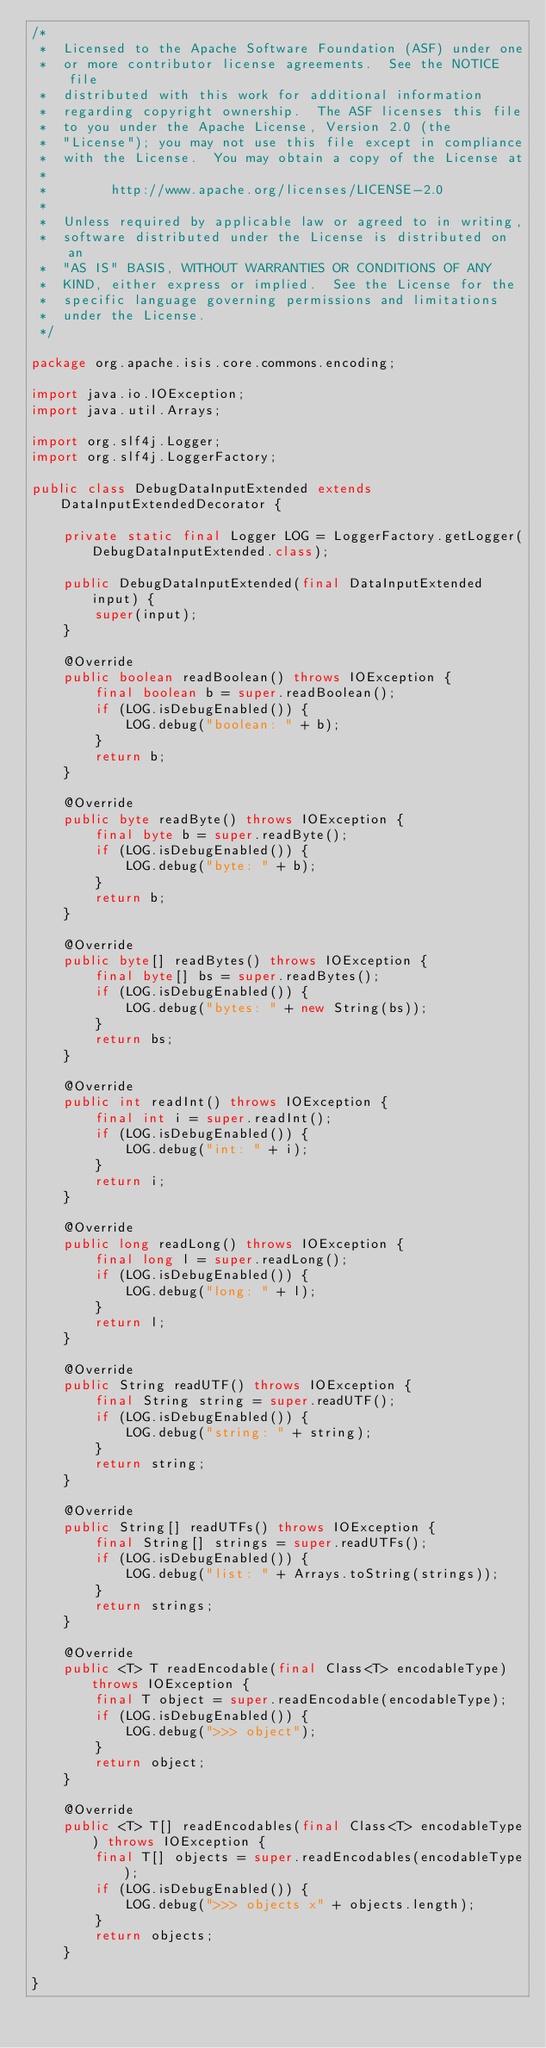Convert code to text. <code><loc_0><loc_0><loc_500><loc_500><_Java_>/*
 *  Licensed to the Apache Software Foundation (ASF) under one
 *  or more contributor license agreements.  See the NOTICE file
 *  distributed with this work for additional information
 *  regarding copyright ownership.  The ASF licenses this file
 *  to you under the Apache License, Version 2.0 (the
 *  "License"); you may not use this file except in compliance
 *  with the License.  You may obtain a copy of the License at
 *
 *        http://www.apache.org/licenses/LICENSE-2.0
 *
 *  Unless required by applicable law or agreed to in writing,
 *  software distributed under the License is distributed on an
 *  "AS IS" BASIS, WITHOUT WARRANTIES OR CONDITIONS OF ANY
 *  KIND, either express or implied.  See the License for the
 *  specific language governing permissions and limitations
 *  under the License.
 */

package org.apache.isis.core.commons.encoding;

import java.io.IOException;
import java.util.Arrays;

import org.slf4j.Logger;
import org.slf4j.LoggerFactory;

public class DebugDataInputExtended extends DataInputExtendedDecorator {

    private static final Logger LOG = LoggerFactory.getLogger(DebugDataInputExtended.class);

    public DebugDataInputExtended(final DataInputExtended input) {
        super(input);
    }

    @Override
    public boolean readBoolean() throws IOException {
        final boolean b = super.readBoolean();
        if (LOG.isDebugEnabled()) {
            LOG.debug("boolean: " + b);
        }
        return b;
    }

    @Override
    public byte readByte() throws IOException {
        final byte b = super.readByte();
        if (LOG.isDebugEnabled()) {
            LOG.debug("byte: " + b);
        }
        return b;
    }

    @Override
    public byte[] readBytes() throws IOException {
        final byte[] bs = super.readBytes();
        if (LOG.isDebugEnabled()) {
            LOG.debug("bytes: " + new String(bs));
        }
        return bs;
    }

    @Override
    public int readInt() throws IOException {
        final int i = super.readInt();
        if (LOG.isDebugEnabled()) {
            LOG.debug("int: " + i);
        }
        return i;
    }

    @Override
    public long readLong() throws IOException {
        final long l = super.readLong();
        if (LOG.isDebugEnabled()) {
            LOG.debug("long: " + l);
        }
        return l;
    }

    @Override
    public String readUTF() throws IOException {
        final String string = super.readUTF();
        if (LOG.isDebugEnabled()) {
            LOG.debug("string: " + string);
        }
        return string;
    }

    @Override
    public String[] readUTFs() throws IOException {
        final String[] strings = super.readUTFs();
        if (LOG.isDebugEnabled()) {
            LOG.debug("list: " + Arrays.toString(strings));
        }
        return strings;
    }

    @Override
    public <T> T readEncodable(final Class<T> encodableType) throws IOException {
        final T object = super.readEncodable(encodableType);
        if (LOG.isDebugEnabled()) {
            LOG.debug(">>> object");
        }
        return object;
    }

    @Override
    public <T> T[] readEncodables(final Class<T> encodableType) throws IOException {
        final T[] objects = super.readEncodables(encodableType);
        if (LOG.isDebugEnabled()) {
            LOG.debug(">>> objects x" + objects.length);
        }
        return objects;
    }

}
</code> 